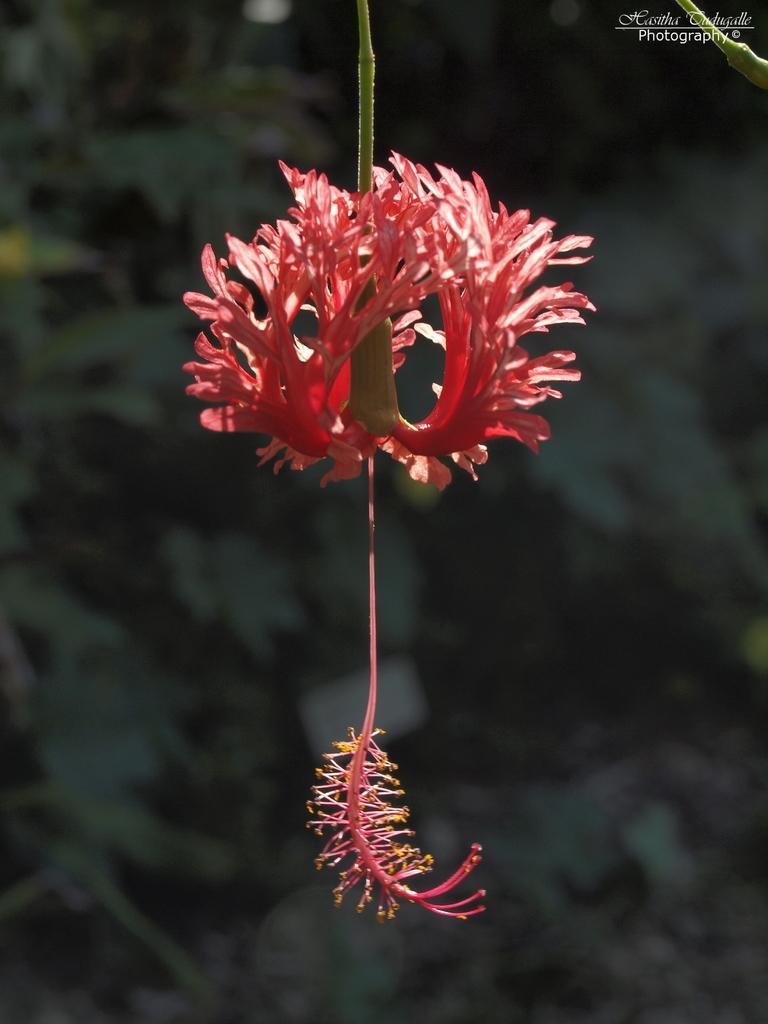In one or two sentences, can you explain what this image depicts? In this image in the front there is a flower. In the background there are leaves and it seems to be blurry. 